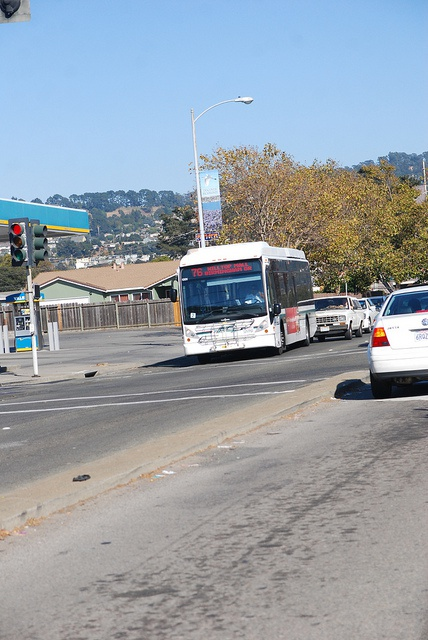Describe the objects in this image and their specific colors. I can see bus in black, white, gray, and blue tones, car in black, white, navy, and gray tones, truck in black, lightgray, gray, and darkgray tones, traffic light in black, gray, darkgray, and red tones, and traffic light in black, gray, and purple tones in this image. 